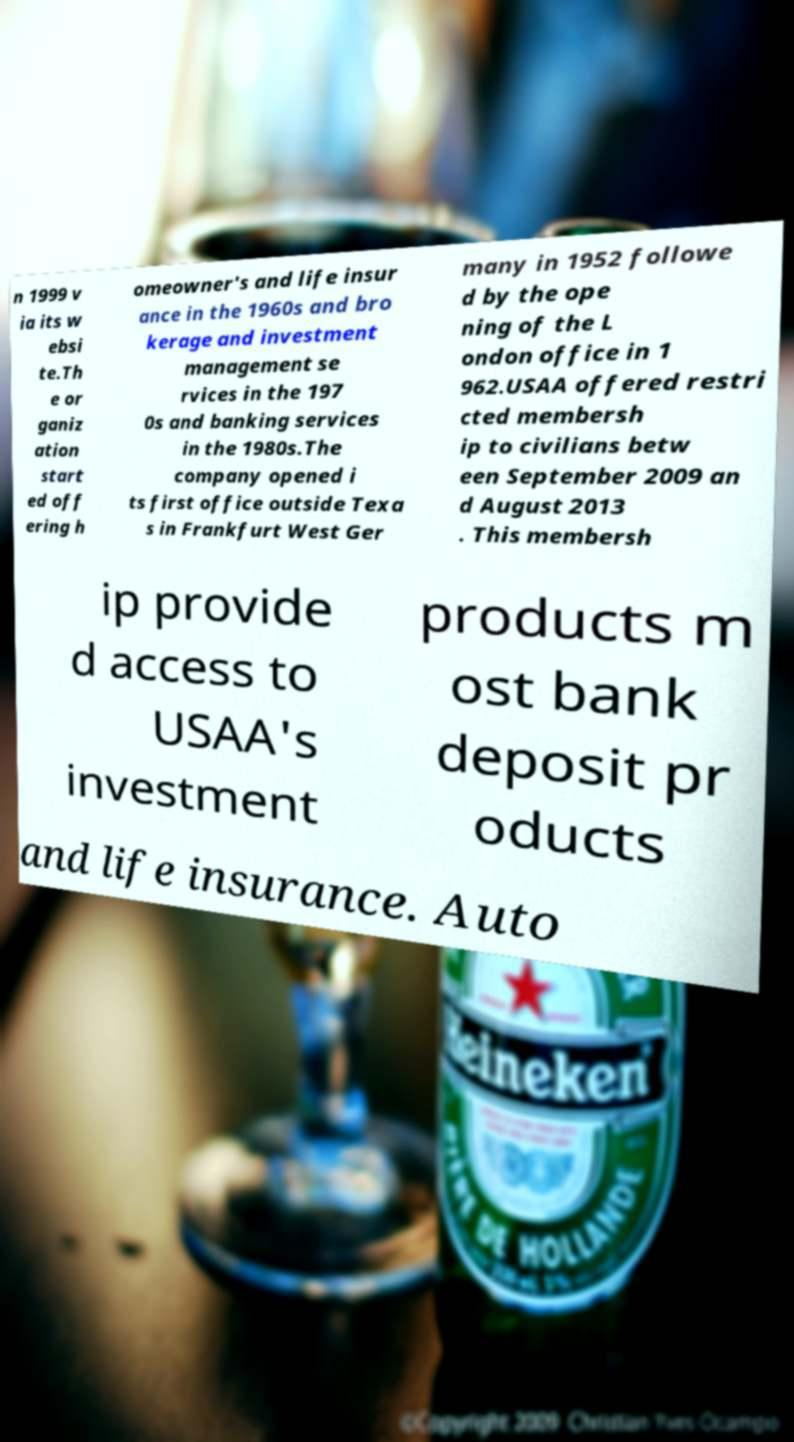Can you read and provide the text displayed in the image?This photo seems to have some interesting text. Can you extract and type it out for me? n 1999 v ia its w ebsi te.Th e or ganiz ation start ed off ering h omeowner's and life insur ance in the 1960s and bro kerage and investment management se rvices in the 197 0s and banking services in the 1980s.The company opened i ts first office outside Texa s in Frankfurt West Ger many in 1952 followe d by the ope ning of the L ondon office in 1 962.USAA offered restri cted membersh ip to civilians betw een September 2009 an d August 2013 . This membersh ip provide d access to USAA's investment products m ost bank deposit pr oducts and life insurance. Auto 